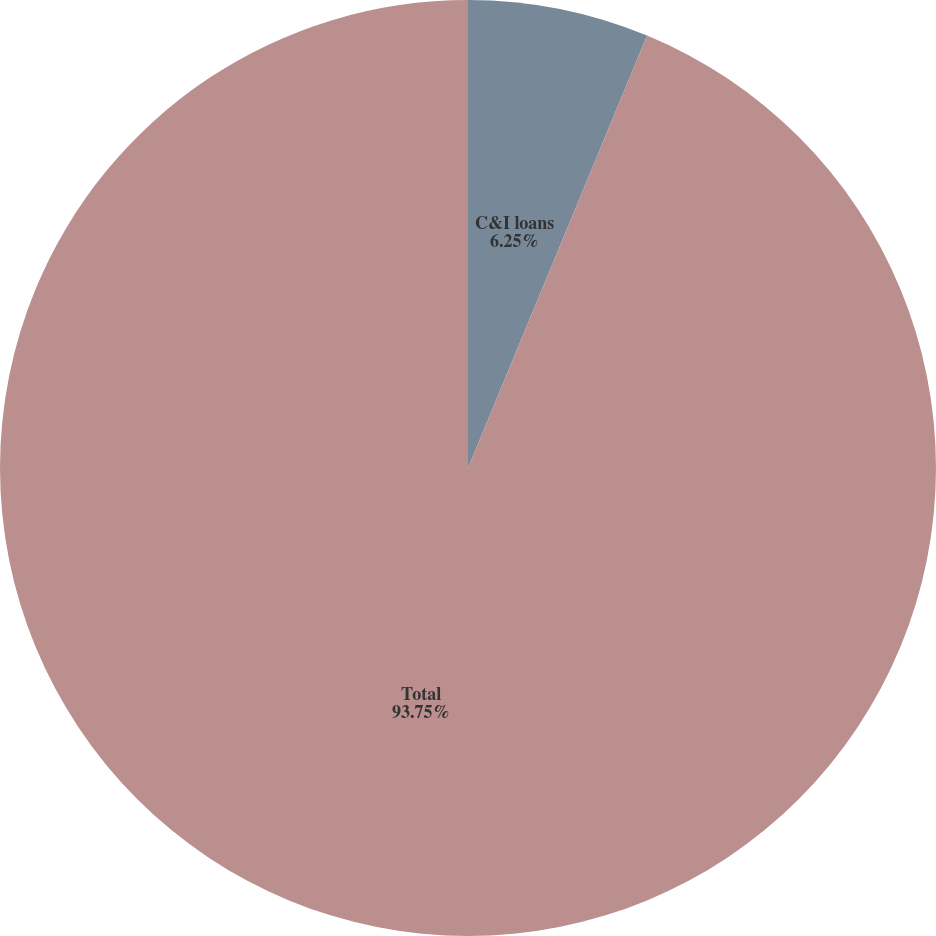Convert chart. <chart><loc_0><loc_0><loc_500><loc_500><pie_chart><fcel>C&I loans<fcel>Total<nl><fcel>6.25%<fcel>93.75%<nl></chart> 